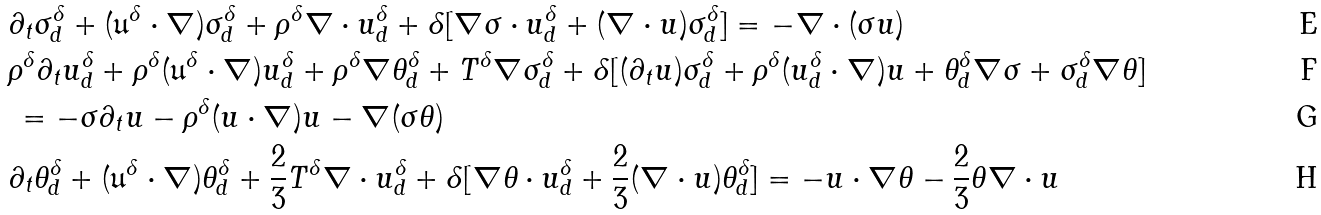<formula> <loc_0><loc_0><loc_500><loc_500>& \partial _ { t } \sigma ^ { \delta } _ { d } + ( \mathfrak { u } ^ { \delta } \cdot \nabla ) \sigma ^ { \delta } _ { d } + \rho ^ { \delta } \nabla \cdot u ^ { \delta } _ { d } + \delta [ \nabla \sigma \cdot u ^ { \delta } _ { d } + ( \nabla \cdot u ) \sigma ^ { \delta } _ { d } ] = - \nabla \cdot ( \sigma u ) \\ & \rho ^ { \delta } \partial _ { t } u ^ { \delta } _ { d } + \rho ^ { \delta } ( \mathfrak { u } ^ { \delta } \cdot \nabla ) u ^ { \delta } _ { d } + \rho ^ { \delta } \nabla \theta ^ { \delta } _ { d } + T ^ { \delta } \nabla \sigma ^ { \delta } _ { d } + \delta [ ( \partial _ { t } u ) \sigma ^ { \delta } _ { d } + \rho ^ { \delta } ( u ^ { \delta } _ { d } \cdot \nabla ) u + \theta ^ { \delta } _ { d } \nabla \sigma + \sigma ^ { \delta } _ { d } \nabla \theta ] \\ & \, = - \sigma \partial _ { t } u - \rho ^ { \delta } ( u \cdot \nabla ) u - \nabla ( \sigma \theta ) \\ & \partial _ { t } \theta ^ { \delta } _ { d } + ( \mathfrak { u } ^ { \delta } \cdot \nabla ) \theta ^ { \delta } _ { d } + \frac { 2 } { 3 } T ^ { \delta } \nabla \cdot u ^ { \delta } _ { d } + \delta [ \nabla \theta \cdot u ^ { \delta } _ { d } + \frac { 2 } { 3 } ( \nabla \cdot u ) \theta ^ { \delta } _ { d } ] = - u \cdot \nabla \theta - \frac { 2 } { 3 } \theta \nabla \cdot u</formula> 